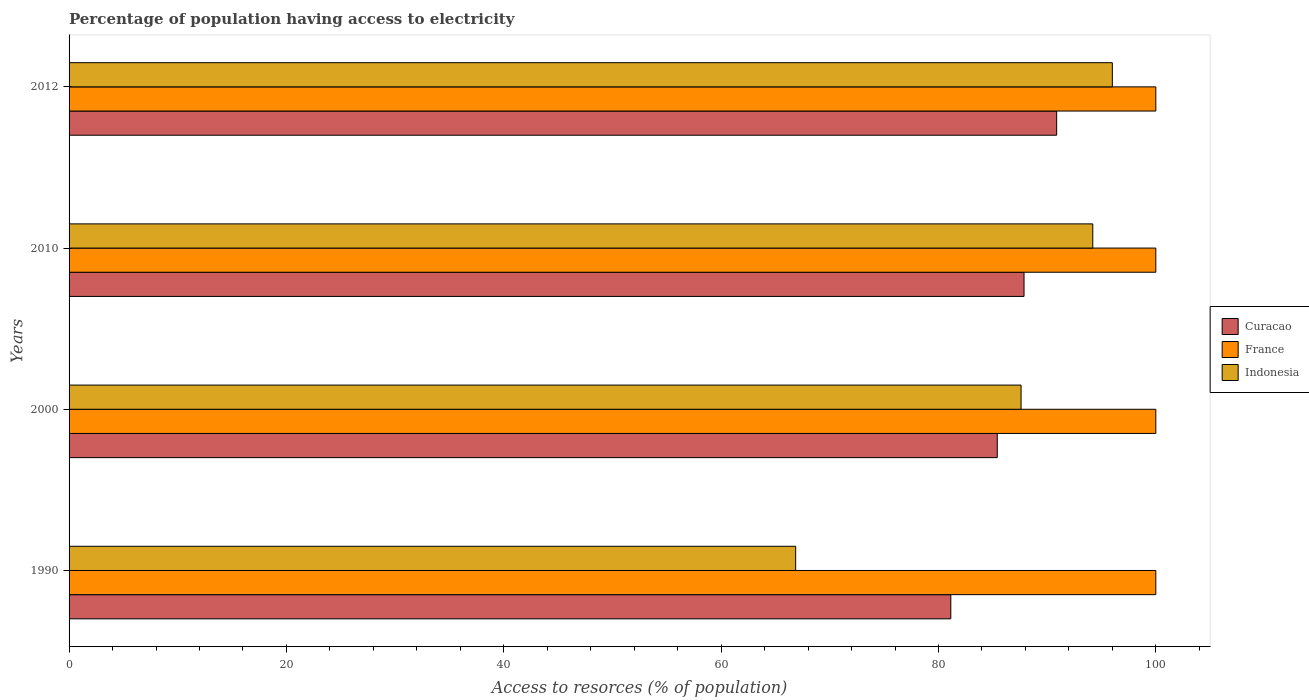How many bars are there on the 1st tick from the bottom?
Make the answer very short. 3. What is the percentage of population having access to electricity in Curacao in 2012?
Offer a very short reply. 90.88. Across all years, what is the maximum percentage of population having access to electricity in Curacao?
Ensure brevity in your answer.  90.88. Across all years, what is the minimum percentage of population having access to electricity in France?
Your response must be concise. 100. In which year was the percentage of population having access to electricity in Indonesia maximum?
Your answer should be compact. 2012. What is the total percentage of population having access to electricity in Curacao in the graph?
Provide a succinct answer. 345.3. What is the difference between the percentage of population having access to electricity in Indonesia in 2010 and the percentage of population having access to electricity in Curacao in 2012?
Provide a short and direct response. 3.32. What is the average percentage of population having access to electricity in Curacao per year?
Ensure brevity in your answer.  86.32. In the year 1990, what is the difference between the percentage of population having access to electricity in Curacao and percentage of population having access to electricity in Indonesia?
Keep it short and to the point. 14.28. What is the ratio of the percentage of population having access to electricity in Indonesia in 1990 to that in 2010?
Ensure brevity in your answer.  0.71. Is the percentage of population having access to electricity in France in 1990 less than that in 2010?
Your answer should be very brief. No. What is the difference between the highest and the second highest percentage of population having access to electricity in Curacao?
Make the answer very short. 3. What is the difference between the highest and the lowest percentage of population having access to electricity in Curacao?
Your response must be concise. 9.74. In how many years, is the percentage of population having access to electricity in Indonesia greater than the average percentage of population having access to electricity in Indonesia taken over all years?
Your response must be concise. 3. Are the values on the major ticks of X-axis written in scientific E-notation?
Give a very brief answer. No. Does the graph contain any zero values?
Make the answer very short. No. Where does the legend appear in the graph?
Your answer should be compact. Center right. How many legend labels are there?
Provide a succinct answer. 3. What is the title of the graph?
Provide a short and direct response. Percentage of population having access to electricity. Does "Mauritius" appear as one of the legend labels in the graph?
Offer a very short reply. No. What is the label or title of the X-axis?
Your answer should be very brief. Access to resorces (% of population). What is the label or title of the Y-axis?
Provide a succinct answer. Years. What is the Access to resorces (% of population) of Curacao in 1990?
Give a very brief answer. 81.14. What is the Access to resorces (% of population) in Indonesia in 1990?
Keep it short and to the point. 66.86. What is the Access to resorces (% of population) in Curacao in 2000?
Give a very brief answer. 85.41. What is the Access to resorces (% of population) of Indonesia in 2000?
Give a very brief answer. 87.6. What is the Access to resorces (% of population) of Curacao in 2010?
Provide a succinct answer. 87.87. What is the Access to resorces (% of population) in Indonesia in 2010?
Give a very brief answer. 94.2. What is the Access to resorces (% of population) of Curacao in 2012?
Provide a short and direct response. 90.88. What is the Access to resorces (% of population) in Indonesia in 2012?
Give a very brief answer. 96. Across all years, what is the maximum Access to resorces (% of population) of Curacao?
Make the answer very short. 90.88. Across all years, what is the maximum Access to resorces (% of population) in Indonesia?
Your answer should be compact. 96. Across all years, what is the minimum Access to resorces (% of population) of Curacao?
Give a very brief answer. 81.14. Across all years, what is the minimum Access to resorces (% of population) of France?
Your answer should be compact. 100. Across all years, what is the minimum Access to resorces (% of population) in Indonesia?
Your response must be concise. 66.86. What is the total Access to resorces (% of population) in Curacao in the graph?
Offer a very short reply. 345.3. What is the total Access to resorces (% of population) in Indonesia in the graph?
Provide a succinct answer. 344.66. What is the difference between the Access to resorces (% of population) of Curacao in 1990 and that in 2000?
Your answer should be compact. -4.28. What is the difference between the Access to resorces (% of population) in France in 1990 and that in 2000?
Your answer should be compact. 0. What is the difference between the Access to resorces (% of population) in Indonesia in 1990 and that in 2000?
Your response must be concise. -20.74. What is the difference between the Access to resorces (% of population) of Curacao in 1990 and that in 2010?
Your answer should be very brief. -6.74. What is the difference between the Access to resorces (% of population) of France in 1990 and that in 2010?
Your answer should be compact. 0. What is the difference between the Access to resorces (% of population) in Indonesia in 1990 and that in 2010?
Your response must be concise. -27.34. What is the difference between the Access to resorces (% of population) of Curacao in 1990 and that in 2012?
Offer a terse response. -9.74. What is the difference between the Access to resorces (% of population) of Indonesia in 1990 and that in 2012?
Make the answer very short. -29.14. What is the difference between the Access to resorces (% of population) of Curacao in 2000 and that in 2010?
Make the answer very short. -2.46. What is the difference between the Access to resorces (% of population) in France in 2000 and that in 2010?
Your answer should be compact. 0. What is the difference between the Access to resorces (% of population) of Indonesia in 2000 and that in 2010?
Provide a succinct answer. -6.6. What is the difference between the Access to resorces (% of population) of Curacao in 2000 and that in 2012?
Your response must be concise. -5.46. What is the difference between the Access to resorces (% of population) in France in 2000 and that in 2012?
Keep it short and to the point. 0. What is the difference between the Access to resorces (% of population) in Curacao in 2010 and that in 2012?
Your response must be concise. -3. What is the difference between the Access to resorces (% of population) in France in 2010 and that in 2012?
Give a very brief answer. 0. What is the difference between the Access to resorces (% of population) in Indonesia in 2010 and that in 2012?
Give a very brief answer. -1.8. What is the difference between the Access to resorces (% of population) in Curacao in 1990 and the Access to resorces (% of population) in France in 2000?
Offer a very short reply. -18.86. What is the difference between the Access to resorces (% of population) in Curacao in 1990 and the Access to resorces (% of population) in Indonesia in 2000?
Provide a succinct answer. -6.46. What is the difference between the Access to resorces (% of population) of Curacao in 1990 and the Access to resorces (% of population) of France in 2010?
Offer a very short reply. -18.86. What is the difference between the Access to resorces (% of population) of Curacao in 1990 and the Access to resorces (% of population) of Indonesia in 2010?
Offer a terse response. -13.06. What is the difference between the Access to resorces (% of population) of Curacao in 1990 and the Access to resorces (% of population) of France in 2012?
Your response must be concise. -18.86. What is the difference between the Access to resorces (% of population) in Curacao in 1990 and the Access to resorces (% of population) in Indonesia in 2012?
Your answer should be compact. -14.86. What is the difference between the Access to resorces (% of population) of Curacao in 2000 and the Access to resorces (% of population) of France in 2010?
Offer a terse response. -14.59. What is the difference between the Access to resorces (% of population) of Curacao in 2000 and the Access to resorces (% of population) of Indonesia in 2010?
Make the answer very short. -8.79. What is the difference between the Access to resorces (% of population) in Curacao in 2000 and the Access to resorces (% of population) in France in 2012?
Make the answer very short. -14.59. What is the difference between the Access to resorces (% of population) in Curacao in 2000 and the Access to resorces (% of population) in Indonesia in 2012?
Make the answer very short. -10.59. What is the difference between the Access to resorces (% of population) in France in 2000 and the Access to resorces (% of population) in Indonesia in 2012?
Your answer should be very brief. 4. What is the difference between the Access to resorces (% of population) of Curacao in 2010 and the Access to resorces (% of population) of France in 2012?
Your answer should be compact. -12.13. What is the difference between the Access to resorces (% of population) of Curacao in 2010 and the Access to resorces (% of population) of Indonesia in 2012?
Offer a very short reply. -8.13. What is the difference between the Access to resorces (% of population) in France in 2010 and the Access to resorces (% of population) in Indonesia in 2012?
Offer a very short reply. 4. What is the average Access to resorces (% of population) in Curacao per year?
Offer a very short reply. 86.32. What is the average Access to resorces (% of population) of France per year?
Make the answer very short. 100. What is the average Access to resorces (% of population) in Indonesia per year?
Your answer should be very brief. 86.17. In the year 1990, what is the difference between the Access to resorces (% of population) in Curacao and Access to resorces (% of population) in France?
Your answer should be compact. -18.86. In the year 1990, what is the difference between the Access to resorces (% of population) in Curacao and Access to resorces (% of population) in Indonesia?
Offer a very short reply. 14.28. In the year 1990, what is the difference between the Access to resorces (% of population) in France and Access to resorces (% of population) in Indonesia?
Your response must be concise. 33.14. In the year 2000, what is the difference between the Access to resorces (% of population) of Curacao and Access to resorces (% of population) of France?
Offer a very short reply. -14.59. In the year 2000, what is the difference between the Access to resorces (% of population) in Curacao and Access to resorces (% of population) in Indonesia?
Make the answer very short. -2.19. In the year 2000, what is the difference between the Access to resorces (% of population) in France and Access to resorces (% of population) in Indonesia?
Make the answer very short. 12.4. In the year 2010, what is the difference between the Access to resorces (% of population) of Curacao and Access to resorces (% of population) of France?
Provide a short and direct response. -12.13. In the year 2010, what is the difference between the Access to resorces (% of population) of Curacao and Access to resorces (% of population) of Indonesia?
Your answer should be very brief. -6.33. In the year 2012, what is the difference between the Access to resorces (% of population) of Curacao and Access to resorces (% of population) of France?
Give a very brief answer. -9.12. In the year 2012, what is the difference between the Access to resorces (% of population) of Curacao and Access to resorces (% of population) of Indonesia?
Your answer should be very brief. -5.12. In the year 2012, what is the difference between the Access to resorces (% of population) of France and Access to resorces (% of population) of Indonesia?
Provide a short and direct response. 4. What is the ratio of the Access to resorces (% of population) in Curacao in 1990 to that in 2000?
Provide a short and direct response. 0.95. What is the ratio of the Access to resorces (% of population) in France in 1990 to that in 2000?
Keep it short and to the point. 1. What is the ratio of the Access to resorces (% of population) in Indonesia in 1990 to that in 2000?
Your response must be concise. 0.76. What is the ratio of the Access to resorces (% of population) in Curacao in 1990 to that in 2010?
Offer a terse response. 0.92. What is the ratio of the Access to resorces (% of population) in Indonesia in 1990 to that in 2010?
Your response must be concise. 0.71. What is the ratio of the Access to resorces (% of population) of Curacao in 1990 to that in 2012?
Offer a terse response. 0.89. What is the ratio of the Access to resorces (% of population) of France in 1990 to that in 2012?
Provide a succinct answer. 1. What is the ratio of the Access to resorces (% of population) in Indonesia in 1990 to that in 2012?
Your answer should be compact. 0.7. What is the ratio of the Access to resorces (% of population) in France in 2000 to that in 2010?
Your answer should be very brief. 1. What is the ratio of the Access to resorces (% of population) in Indonesia in 2000 to that in 2010?
Ensure brevity in your answer.  0.93. What is the ratio of the Access to resorces (% of population) of Curacao in 2000 to that in 2012?
Provide a succinct answer. 0.94. What is the ratio of the Access to resorces (% of population) in Indonesia in 2000 to that in 2012?
Give a very brief answer. 0.91. What is the ratio of the Access to resorces (% of population) in Curacao in 2010 to that in 2012?
Ensure brevity in your answer.  0.97. What is the ratio of the Access to resorces (% of population) of France in 2010 to that in 2012?
Make the answer very short. 1. What is the ratio of the Access to resorces (% of population) in Indonesia in 2010 to that in 2012?
Give a very brief answer. 0.98. What is the difference between the highest and the second highest Access to resorces (% of population) in Curacao?
Offer a very short reply. 3. What is the difference between the highest and the second highest Access to resorces (% of population) in France?
Your response must be concise. 0. What is the difference between the highest and the lowest Access to resorces (% of population) in Curacao?
Your answer should be very brief. 9.74. What is the difference between the highest and the lowest Access to resorces (% of population) of Indonesia?
Make the answer very short. 29.14. 